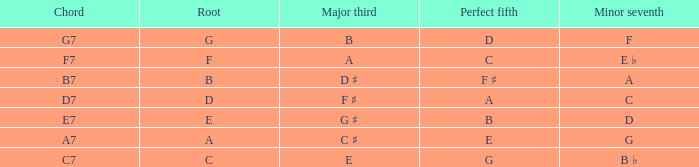What is the major third alongside a perfect fifth that is d? B. 